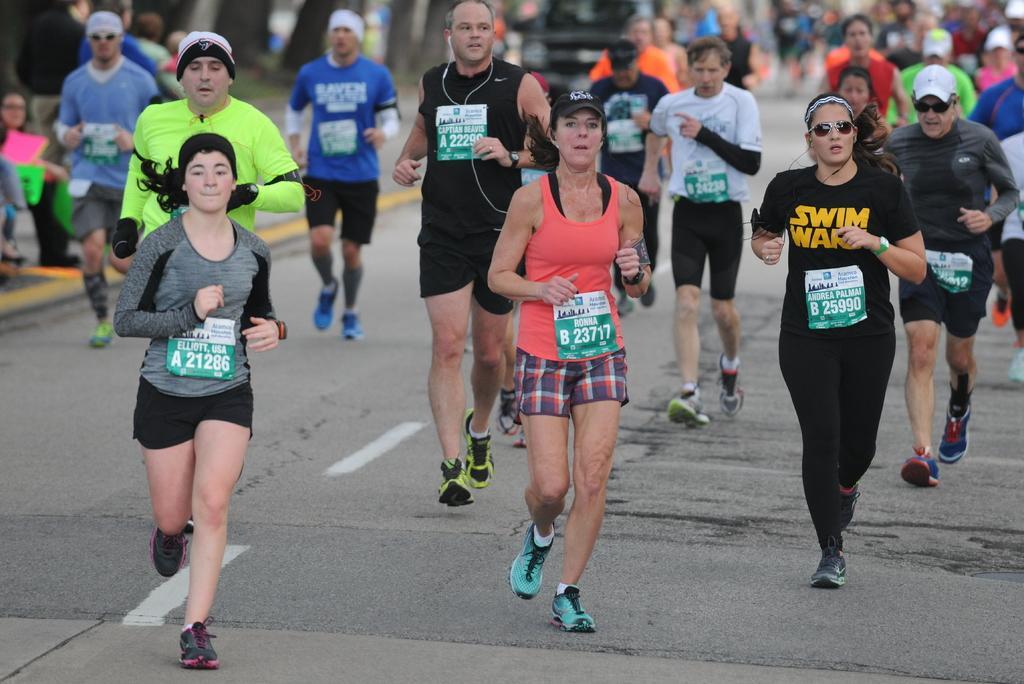In one or two sentences, can you explain what this image depicts? In this image we can see there are people running on the road and at the back it looks like a blur. 